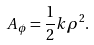<formula> <loc_0><loc_0><loc_500><loc_500>A _ { \phi } = \frac { 1 } { 2 } k \rho ^ { 2 } .</formula> 